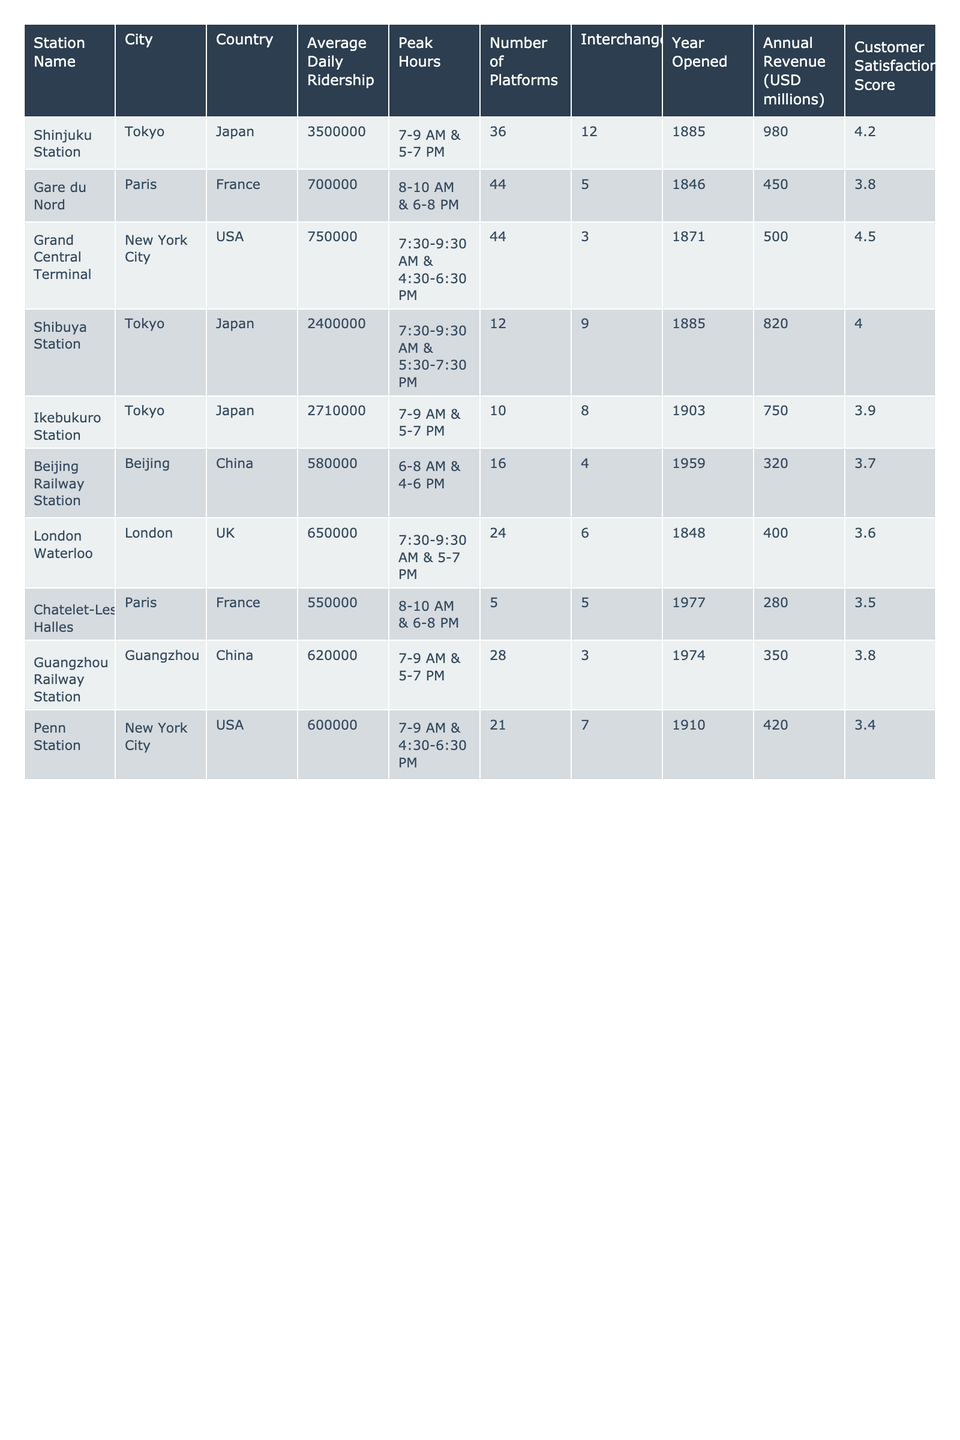What is the average daily ridership of Shinjuku Station? The table shows that Shinjuku Station has an average daily ridership of 3,500,000.
Answer: 3,500,000 Which city has the train station with the highest average daily ridership? According to the table, Shinjuku Station located in Tokyo has the highest average daily ridership of 3,500,000.
Answer: Tokyo How many platforms does Grand Central Terminal have? The table indicates that Grand Central Terminal has 44 platforms.
Answer: 44 Is the average daily ridership of Guangzhou Railway Station greater than that of Penn Station? The average daily ridership for Guangzhou Railway Station is 620,000, and for Penn Station, it is 600,000, so yes, Guangzhou Railway Station has a higher ridership.
Answer: Yes What is the total average daily ridership of the top 3 busiest stations? The total average daily ridership is 3,500,000 (Shinjuku) + 2,400,000 (Shibuya) + 2,710,000 (Ikebukuro) = 8,610,000.
Answer: 8,610,000 Which station has the lowest customer satisfaction score? The customer satisfaction scores from the table show that Penn Station has the lowest score of 3.4.
Answer: Penn Station What is the average number of platforms across all stations listed? The total number of platforms is 36 + 44 + 44 + 12 + 10 + 16 + 24 + 5 + 28 + 21 =  144. There are 10 stations, so the average is 144/10 = 14.4.
Answer: 14.4 Is it true that all stations listed have been operational since before 2000? The table shows that all listed stations opened before 2000, confirming that the statement is true.
Answer: Yes What is the difference in average daily ridership between the busiest and the least busy station? The difference is 3,500,000 (Shinjuku) - 600,000 (Penn Station) = 2,900,000.
Answer: 2,900,000 Which station has the highest annual revenue? The table indicates that Shinjuku Station generates the highest annual revenue of 980 million USD.
Answer: Shinjuku Station 